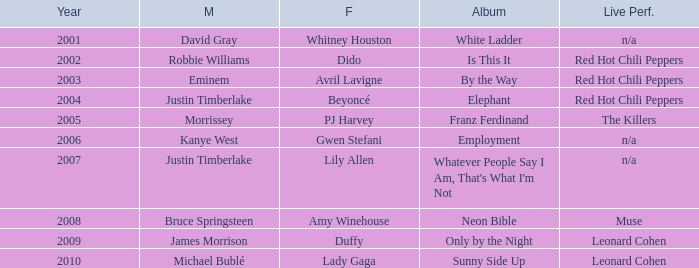Can you give me this table as a dict? {'header': ['Year', 'M', 'F', 'Album', 'Live Perf.'], 'rows': [['2001', 'David Gray', 'Whitney Houston', 'White Ladder', 'n/a'], ['2002', 'Robbie Williams', 'Dido', 'Is This It', 'Red Hot Chili Peppers'], ['2003', 'Eminem', 'Avril Lavigne', 'By the Way', 'Red Hot Chili Peppers'], ['2004', 'Justin Timberlake', 'Beyoncé', 'Elephant', 'Red Hot Chili Peppers'], ['2005', 'Morrissey', 'PJ Harvey', 'Franz Ferdinand', 'The Killers'], ['2006', 'Kanye West', 'Gwen Stefani', 'Employment', 'n/a'], ['2007', 'Justin Timberlake', 'Lily Allen', "Whatever People Say I Am, That's What I'm Not", 'n/a'], ['2008', 'Bruce Springsteen', 'Amy Winehouse', 'Neon Bible', 'Muse'], ['2009', 'James Morrison', 'Duffy', 'Only by the Night', 'Leonard Cohen'], ['2010', 'Michael Bublé', 'Lady Gaga', 'Sunny Side Up', 'Leonard Cohen']]} Who is the male partner for amy winehouse? Bruce Springsteen. 